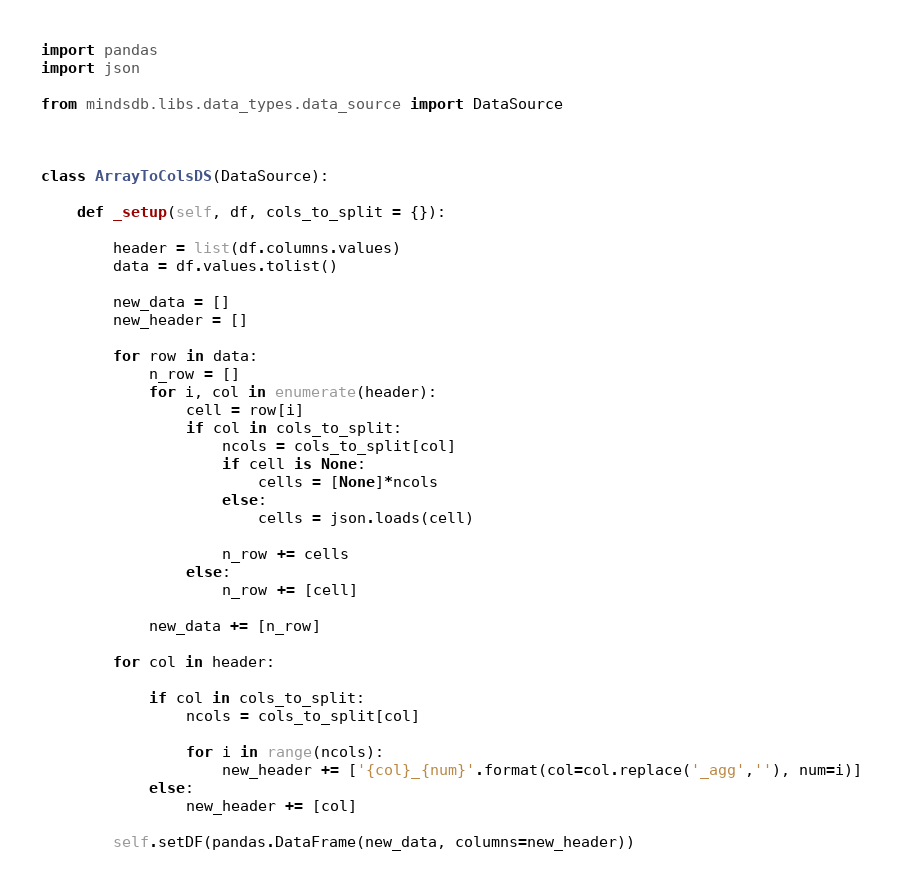<code> <loc_0><loc_0><loc_500><loc_500><_Python_>import pandas
import json

from mindsdb.libs.data_types.data_source import DataSource



class ArrayToColsDS(DataSource):

    def _setup(self, df, cols_to_split = {}):

        header = list(df.columns.values)
        data = df.values.tolist()

        new_data = []
        new_header = []

        for row in data:
            n_row = []
            for i, col in enumerate(header):
                cell = row[i]
                if col in cols_to_split:
                    ncols = cols_to_split[col]
                    if cell is None:
                        cells = [None]*ncols
                    else:
                        cells = json.loads(cell)

                    n_row += cells
                else:
                    n_row += [cell]

            new_data += [n_row]

        for col in header:

            if col in cols_to_split:
                ncols = cols_to_split[col]

                for i in range(ncols):
                    new_header += ['{col}_{num}'.format(col=col.replace('_agg',''), num=i)]
            else:
                new_header += [col]

        self.setDF(pandas.DataFrame(new_data, columns=new_header))

</code> 